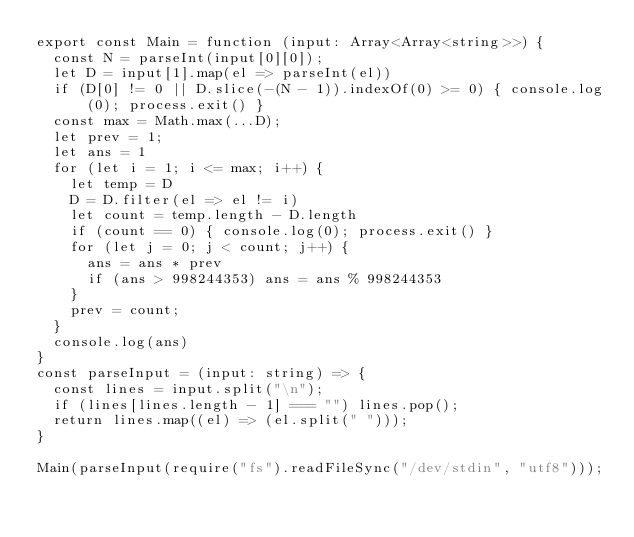<code> <loc_0><loc_0><loc_500><loc_500><_TypeScript_>export const Main = function (input: Array<Array<string>>) {
  const N = parseInt(input[0][0]);
  let D = input[1].map(el => parseInt(el))
  if (D[0] != 0 || D.slice(-(N - 1)).indexOf(0) >= 0) { console.log(0); process.exit() }
  const max = Math.max(...D);
  let prev = 1;
  let ans = 1
  for (let i = 1; i <= max; i++) {
    let temp = D
    D = D.filter(el => el != i)
    let count = temp.length - D.length
    if (count == 0) { console.log(0); process.exit() }
    for (let j = 0; j < count; j++) {
      ans = ans * prev
      if (ans > 998244353) ans = ans % 998244353
    }
    prev = count;
  }
  console.log(ans)
}
const parseInput = (input: string) => {
  const lines = input.split("\n");
  if (lines[lines.length - 1] === "") lines.pop();
  return lines.map((el) => (el.split(" ")));
}

Main(parseInput(require("fs").readFileSync("/dev/stdin", "utf8")));
</code> 